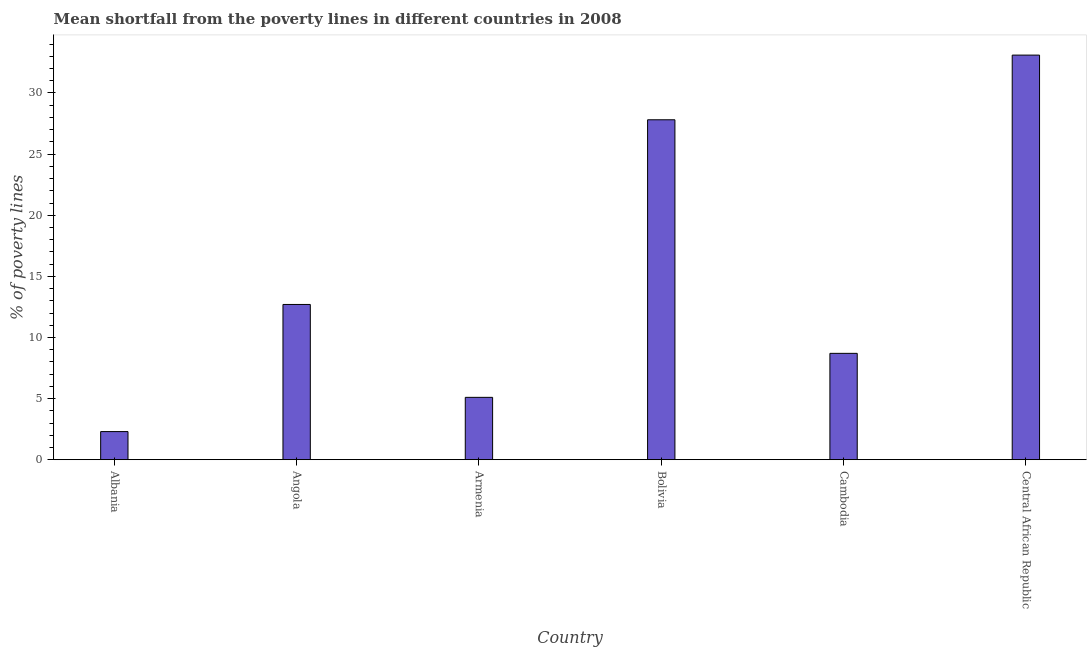Does the graph contain grids?
Your answer should be very brief. No. What is the title of the graph?
Provide a short and direct response. Mean shortfall from the poverty lines in different countries in 2008. What is the label or title of the Y-axis?
Offer a terse response. % of poverty lines. Across all countries, what is the maximum poverty gap at national poverty lines?
Offer a very short reply. 33.1. Across all countries, what is the minimum poverty gap at national poverty lines?
Offer a terse response. 2.3. In which country was the poverty gap at national poverty lines maximum?
Ensure brevity in your answer.  Central African Republic. In which country was the poverty gap at national poverty lines minimum?
Keep it short and to the point. Albania. What is the sum of the poverty gap at national poverty lines?
Give a very brief answer. 89.71. What is the difference between the poverty gap at national poverty lines in Bolivia and Central African Republic?
Keep it short and to the point. -5.29. What is the average poverty gap at national poverty lines per country?
Your answer should be compact. 14.95. In how many countries, is the poverty gap at national poverty lines greater than 28 %?
Ensure brevity in your answer.  1. What is the ratio of the poverty gap at national poverty lines in Angola to that in Central African Republic?
Your answer should be very brief. 0.38. Is the poverty gap at national poverty lines in Armenia less than that in Cambodia?
Offer a terse response. Yes. What is the difference between the highest and the second highest poverty gap at national poverty lines?
Keep it short and to the point. 5.29. Is the sum of the poverty gap at national poverty lines in Albania and Central African Republic greater than the maximum poverty gap at national poverty lines across all countries?
Keep it short and to the point. Yes. What is the difference between the highest and the lowest poverty gap at national poverty lines?
Your answer should be compact. 30.8. Are all the bars in the graph horizontal?
Keep it short and to the point. No. How many countries are there in the graph?
Your response must be concise. 6. Are the values on the major ticks of Y-axis written in scientific E-notation?
Provide a short and direct response. No. What is the % of poverty lines of Albania?
Offer a terse response. 2.3. What is the % of poverty lines of Armenia?
Your answer should be compact. 5.1. What is the % of poverty lines in Bolivia?
Provide a succinct answer. 27.81. What is the % of poverty lines of Cambodia?
Keep it short and to the point. 8.7. What is the % of poverty lines of Central African Republic?
Keep it short and to the point. 33.1. What is the difference between the % of poverty lines in Albania and Angola?
Keep it short and to the point. -10.4. What is the difference between the % of poverty lines in Albania and Bolivia?
Your answer should be very brief. -25.51. What is the difference between the % of poverty lines in Albania and Cambodia?
Give a very brief answer. -6.4. What is the difference between the % of poverty lines in Albania and Central African Republic?
Your answer should be very brief. -30.8. What is the difference between the % of poverty lines in Angola and Bolivia?
Give a very brief answer. -15.11. What is the difference between the % of poverty lines in Angola and Central African Republic?
Provide a succinct answer. -20.4. What is the difference between the % of poverty lines in Armenia and Bolivia?
Offer a terse response. -22.71. What is the difference between the % of poverty lines in Armenia and Cambodia?
Give a very brief answer. -3.6. What is the difference between the % of poverty lines in Armenia and Central African Republic?
Give a very brief answer. -28. What is the difference between the % of poverty lines in Bolivia and Cambodia?
Your response must be concise. 19.11. What is the difference between the % of poverty lines in Bolivia and Central African Republic?
Offer a terse response. -5.29. What is the difference between the % of poverty lines in Cambodia and Central African Republic?
Give a very brief answer. -24.4. What is the ratio of the % of poverty lines in Albania to that in Angola?
Offer a very short reply. 0.18. What is the ratio of the % of poverty lines in Albania to that in Armenia?
Your answer should be very brief. 0.45. What is the ratio of the % of poverty lines in Albania to that in Bolivia?
Ensure brevity in your answer.  0.08. What is the ratio of the % of poverty lines in Albania to that in Cambodia?
Make the answer very short. 0.26. What is the ratio of the % of poverty lines in Albania to that in Central African Republic?
Provide a succinct answer. 0.07. What is the ratio of the % of poverty lines in Angola to that in Armenia?
Your answer should be compact. 2.49. What is the ratio of the % of poverty lines in Angola to that in Bolivia?
Make the answer very short. 0.46. What is the ratio of the % of poverty lines in Angola to that in Cambodia?
Keep it short and to the point. 1.46. What is the ratio of the % of poverty lines in Angola to that in Central African Republic?
Your answer should be very brief. 0.38. What is the ratio of the % of poverty lines in Armenia to that in Bolivia?
Make the answer very short. 0.18. What is the ratio of the % of poverty lines in Armenia to that in Cambodia?
Your response must be concise. 0.59. What is the ratio of the % of poverty lines in Armenia to that in Central African Republic?
Keep it short and to the point. 0.15. What is the ratio of the % of poverty lines in Bolivia to that in Cambodia?
Ensure brevity in your answer.  3.2. What is the ratio of the % of poverty lines in Bolivia to that in Central African Republic?
Your answer should be compact. 0.84. What is the ratio of the % of poverty lines in Cambodia to that in Central African Republic?
Ensure brevity in your answer.  0.26. 